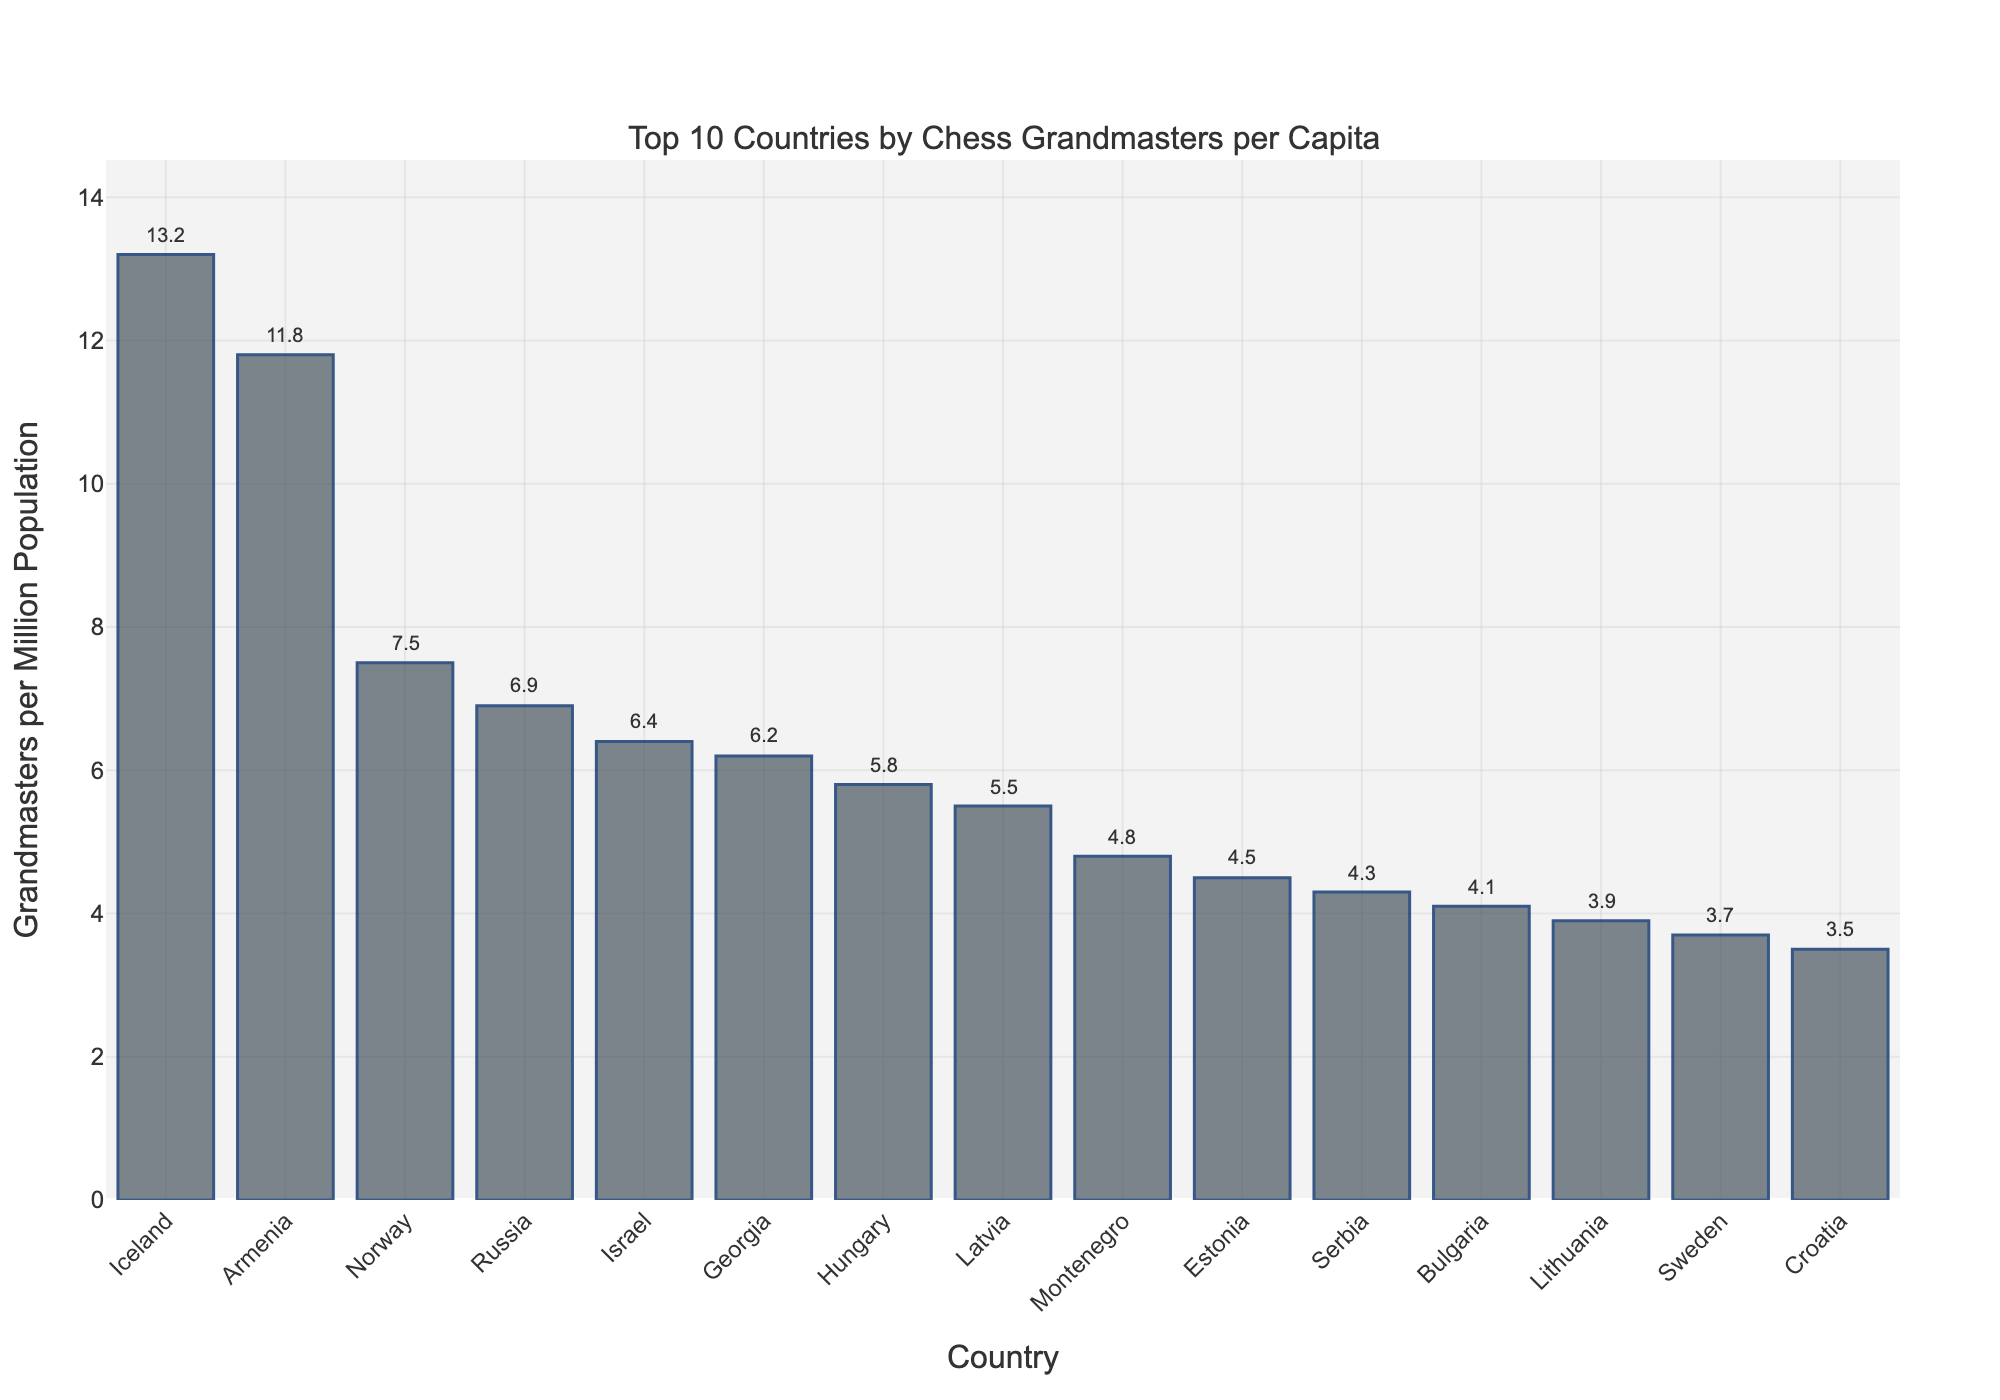Which country has the highest number of chess grandmasters per capita? The highest bar in the chart represents the country with the highest number of chess grandmasters per capita. This bar corresponds to Iceland.
Answer: Iceland Which country ranks fourth in terms of chess grandmasters per capita? The fourth highest bar in the chart represents the country that ranks fourth in terms of chess grandmasters per capita. This bar corresponds to Russia.
Answer: Russia How many chess grandmasters per million population does Armenia have? Locate the bar corresponding to Armenia and read the value on the y-axis: Armenia has 11.8 chess grandmasters per million population.
Answer: 11.8 What is the difference in the number of grandmasters per million population between Iceland and Norway? Iceland has 13.2 grandmasters per million, and Norway has 7.5 grandmasters per million. Subtract Norway's value from Iceland's: 13.2 - 7.5 = 5.7.
Answer: 5.7 What is the average number of grandmasters per million population for the top 5 countries? Find the number of grandmasters per million for Iceland, Armenia, Norway, Russia, and Israel, which are 13.2, 11.8, 7.5, 6.9, and 6.4. Sum these values and divide by 5: (13.2 + 11.8 + 7.5 + 6.9 + 6.4) / 5 = 45.8 / 5 = 9.16.
Answer: 9.16 How does the number of grandmasters per million population in Georgia compare to that in Latvia? Georgia has 6.2 grandmasters per million and Latvia has 5.5 grandmasters per million. 6.2 is greater than 5.5.
Answer: Georgia has more What is the combined number of grandmasters per million population for Estonia and Lithuania? Find the values for Estonia (4.5) and Lithuania (3.9), then sum them: 4.5 + 3.9 = 8.4.
Answer: 8.4 Which country has slightly fewer chess grandmasters per capita, Lithuania or Bulgaria? Lithuania has 3.9 grandmasters per million, and Bulgaria has 4.1 grandmasters per million. 3.9 is less than 4.1.
Answer: Lithuania What is the total number of chess grandmasters per million population for the last three countries listed in the figure? The last three countries are Serbia (4.3), Bulgaria (4.1), and Lithuania (3.9). Sum these values: 4.3 + 4.1 + 3.9 = 12.3.
Answer: 12.3 Which country has a similar number of grandmasters per million population as Sweden? Sweden has 3.7 grandmasters per million. Croatia, with 3.5 grandmasters per million, has a similar value.
Answer: Croatia 